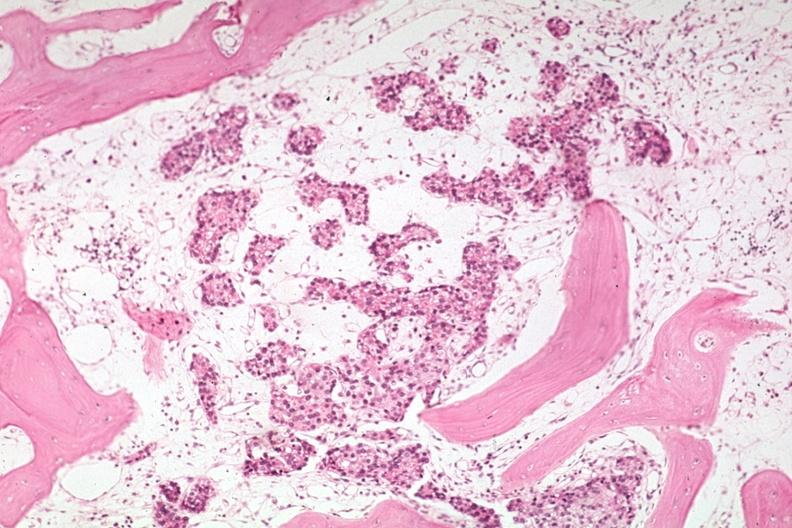how does this image show med metastasis in marrow?
Answer the question using a single word or phrase. With no evidence of osteoblastic activity 15l893 